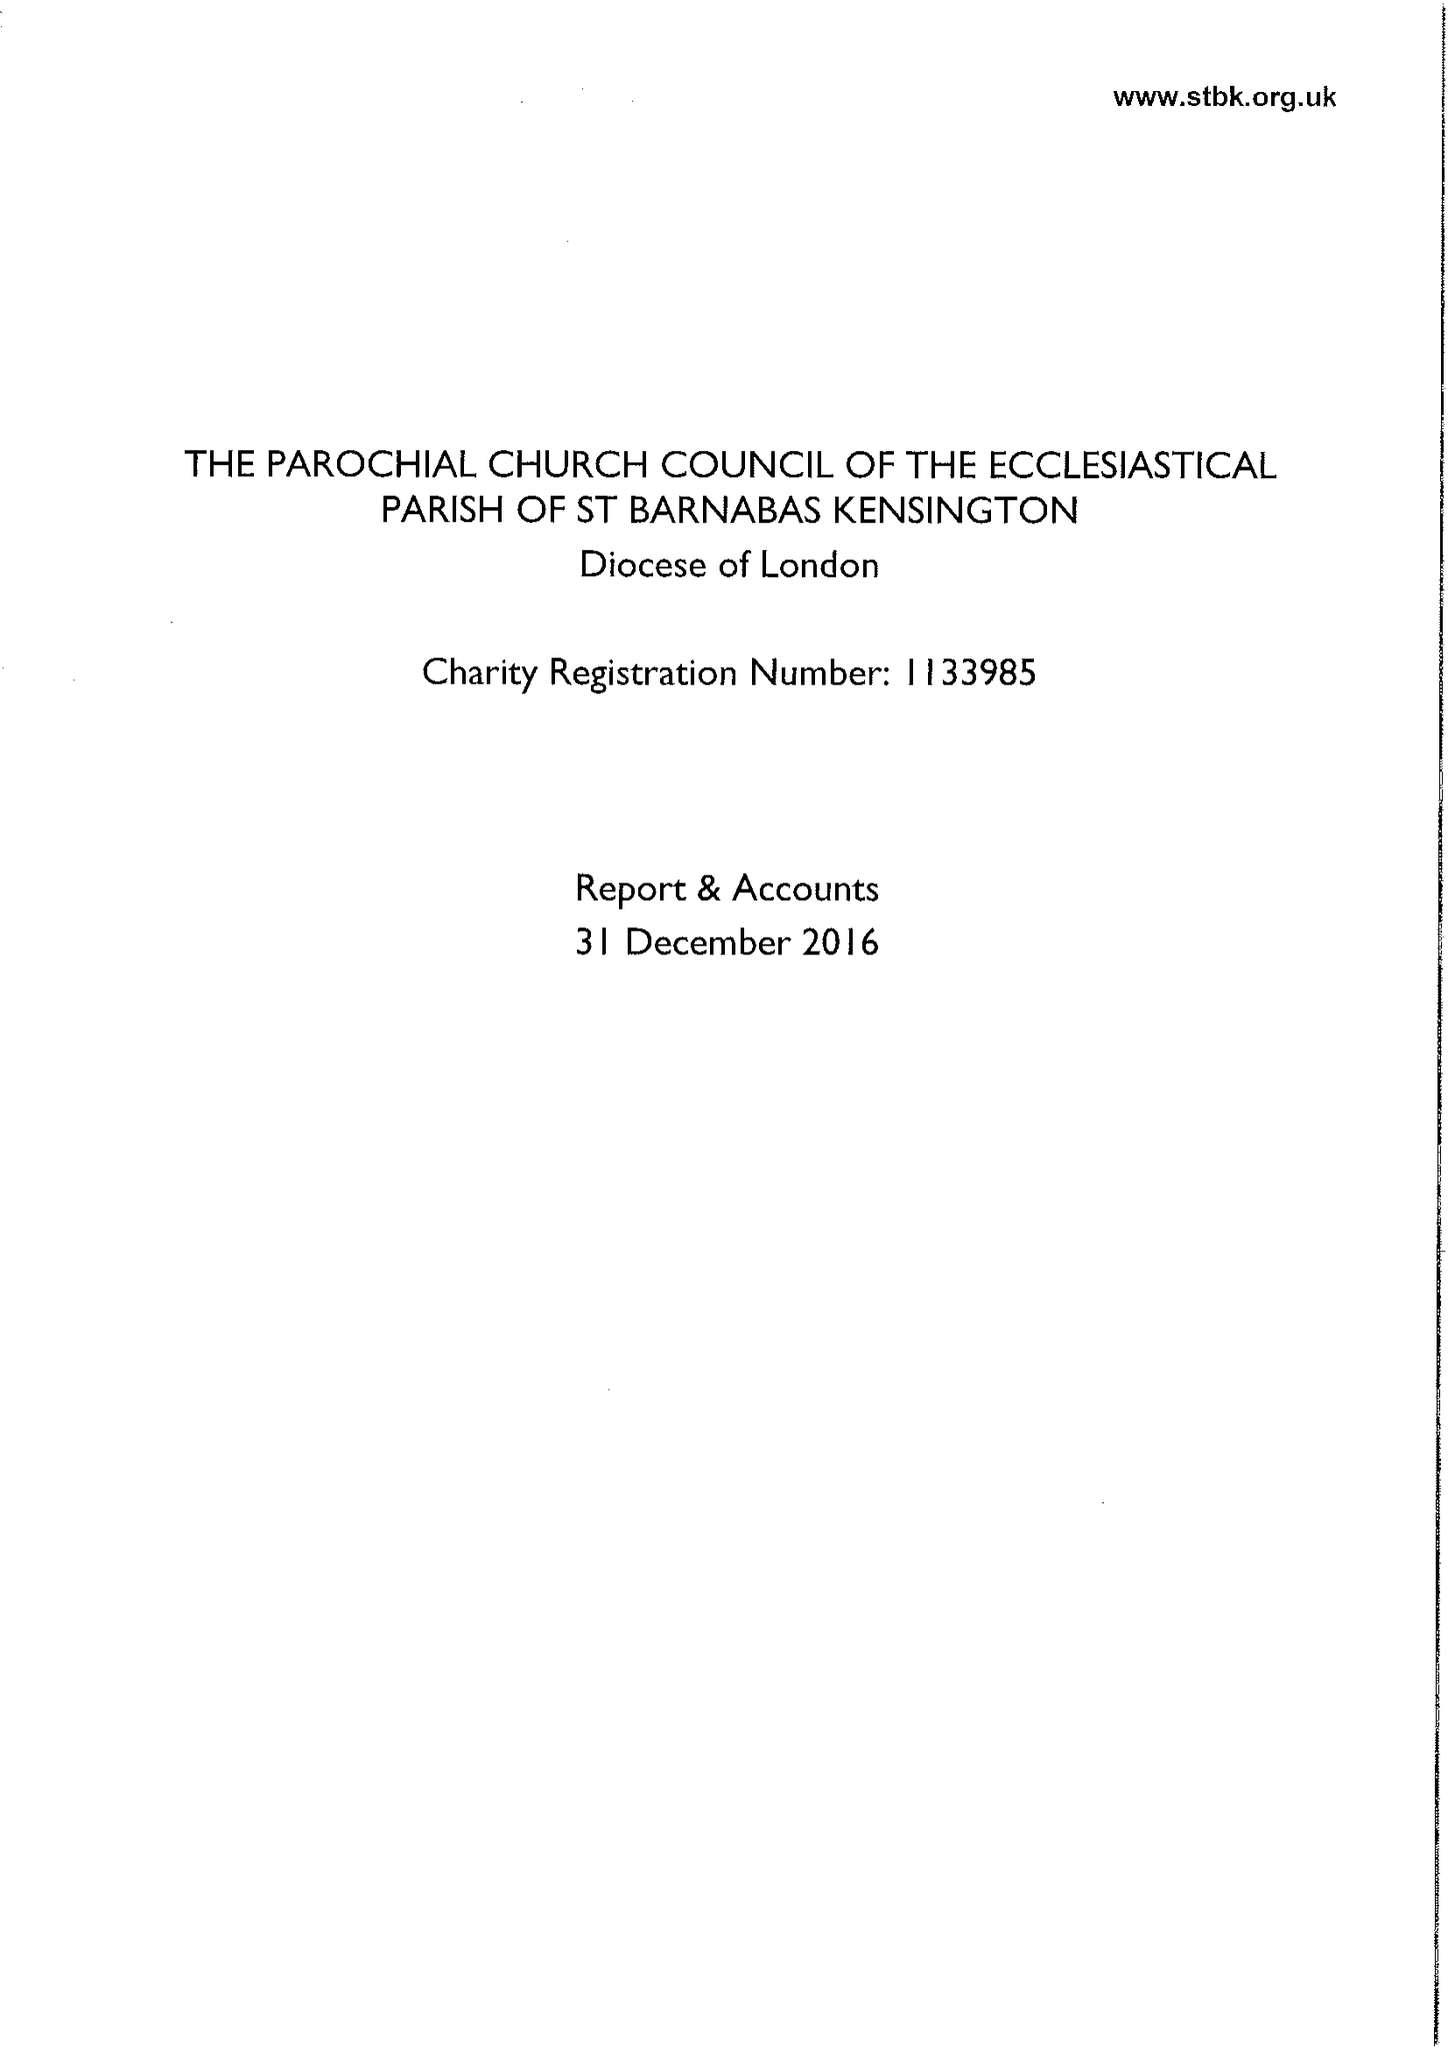What is the value for the address__postcode?
Answer the question using a single word or phrase. W14 8LH 